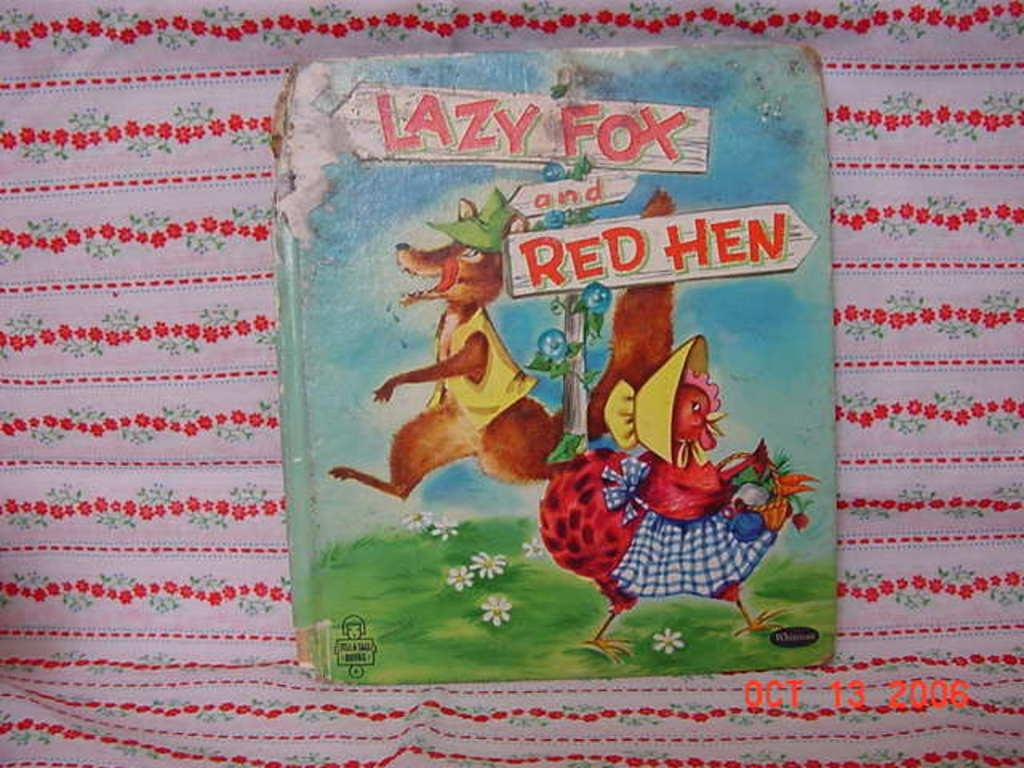What is the main object in the image? There is a book in the image. What can be seen on the cover of the book? The book has a cartoon image on it. Are there any words or names on the book? Yes, there are names printed on the book. On what surface is the book placed? The book is on a cloth surface. Can you see a pig on the roof in the image? There is no pig or roof present in the image. 